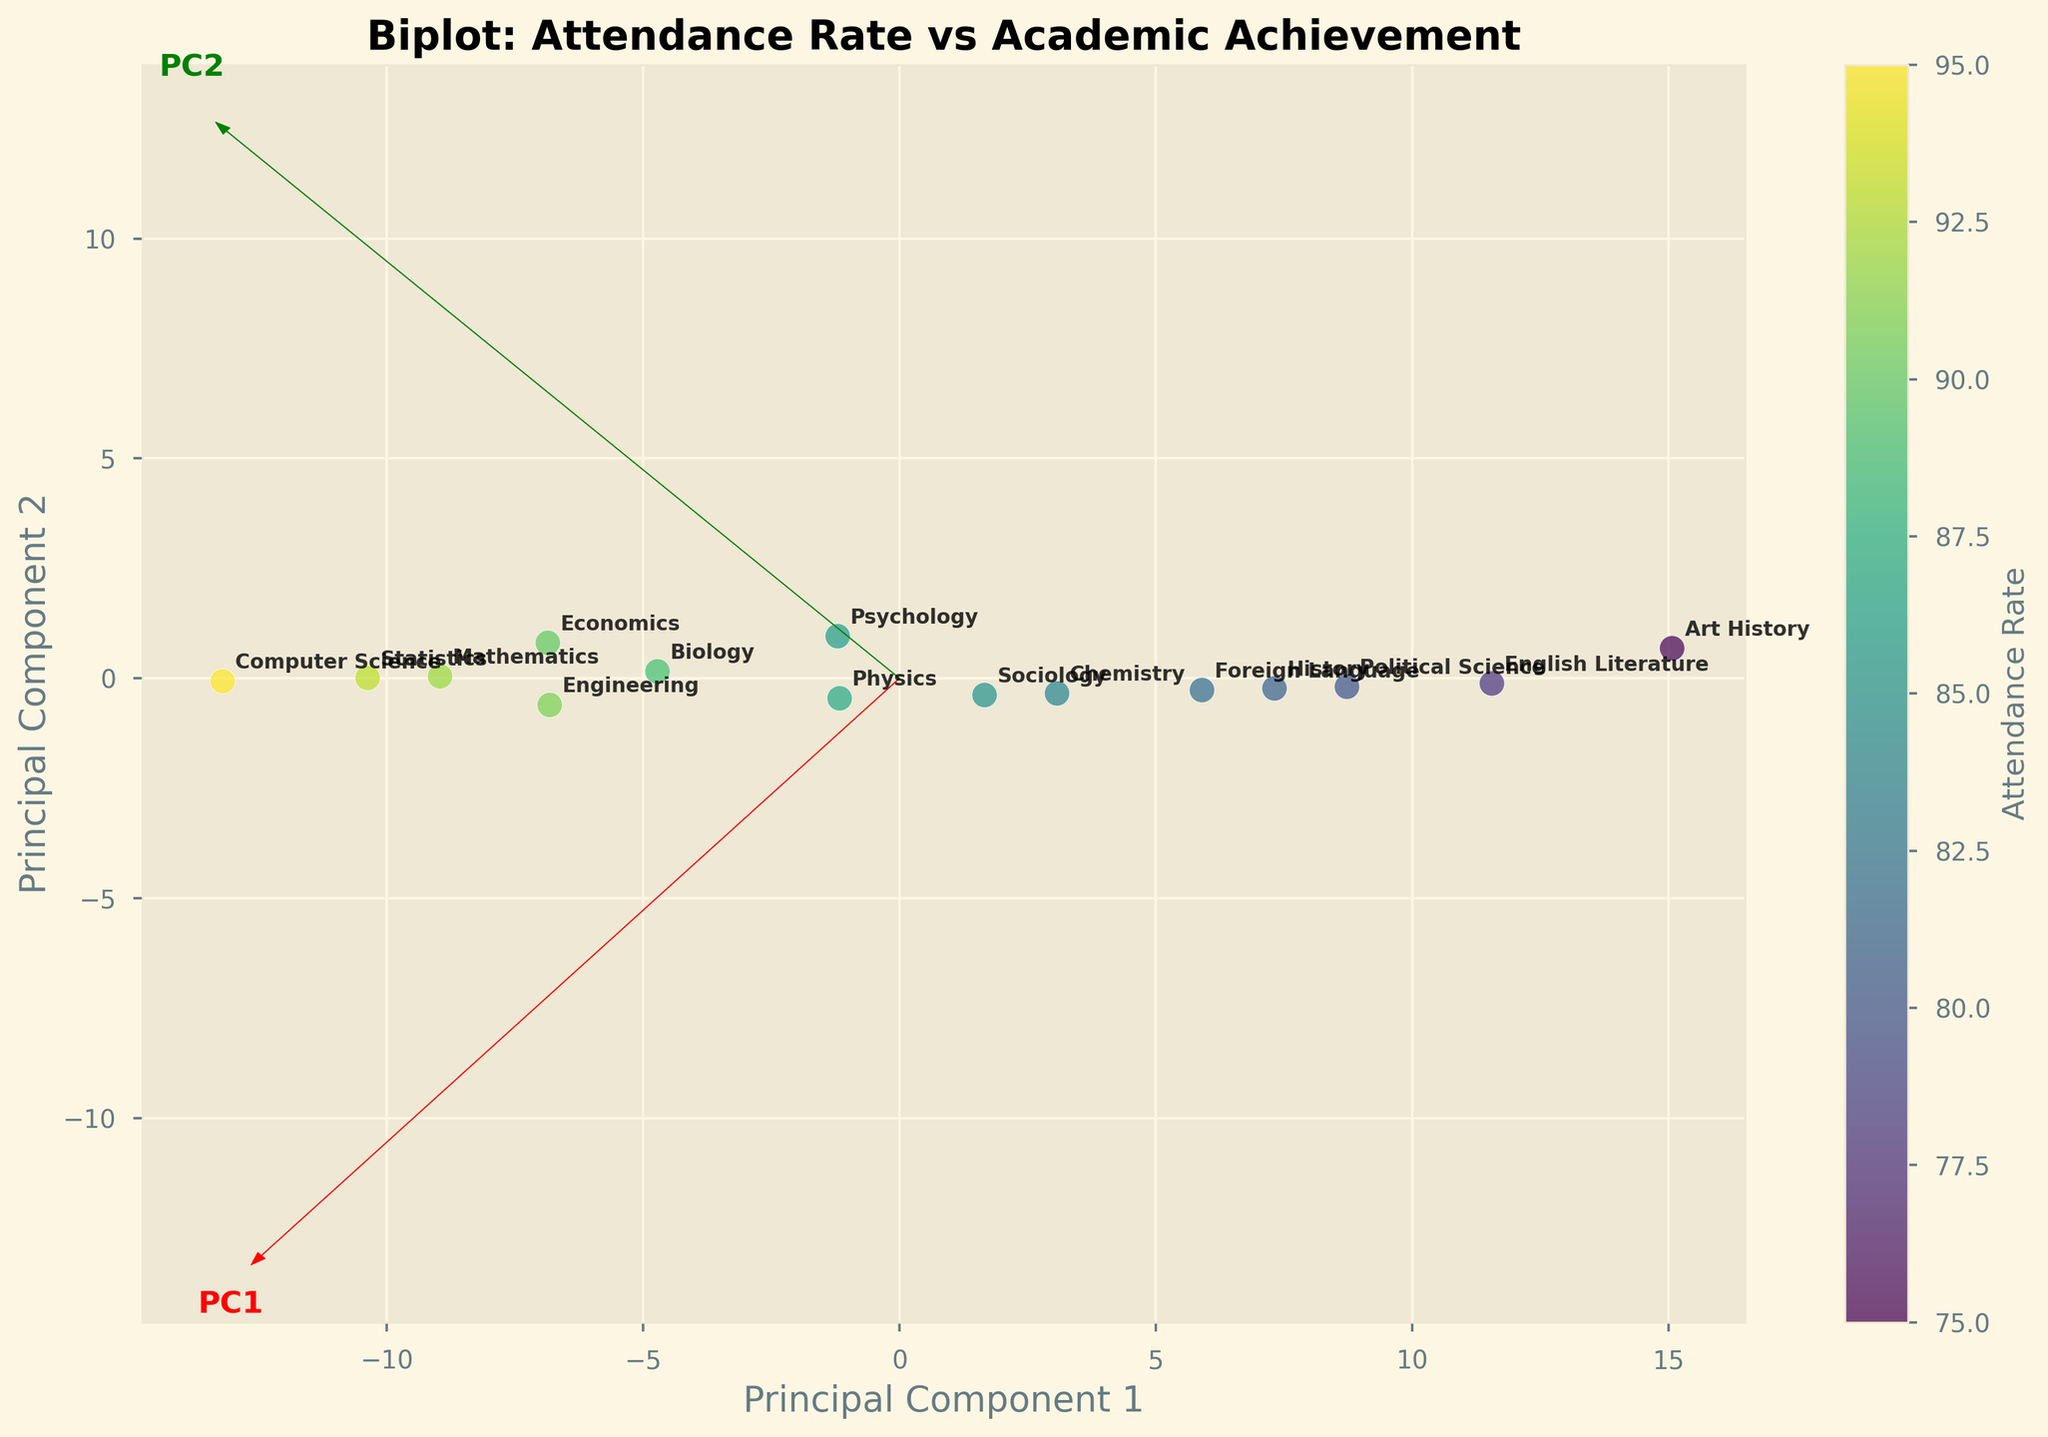What's the title of the figure? The title is displayed at the top of the figure. It reads "Biplot: Attendance Rate vs Academic Achievement".
Answer: Biplot: Attendance Rate vs Academic Achievement How many courses are represented in the plot? Each course is represented by a data point on the plot. By counting the points or the labels, we can see there are 15 courses.
Answer: 15 Which course has the highest attendance rate? By referring to the color bar and the corresponding labels on the plot, we can identify that "Computer Science" is represented by the brightest color indicating the highest attendance rate of 95%.
Answer: Computer Science Which principal component appears to explain the most variance in the data? The length of the arrows for each principal component (shown in red for PC1 and green for PC2) indicates the amount of variance they explain. The longer the arrow, the more variance explained. The red arrow (PC1) is longer.
Answer: PC1 Is the attendance rate for "Art History" above or below the median attendance rate for all courses? To find the median attendance rate, we consider the middle value of all sorted attendance rates (75, 78, 80, 81, 82, 84, 85, 86, 87, 89, 90, 91, 92, 93, 95). The median is 86 (8th value). The attendance rate for "Art History" is 75, which is below the median.
Answer: Below Compare the academic achievement of "English Literature" and "Statistics". Which course has a higher score? By locating the positions of "English Literature" and "Statistics" on the plot and checking their respective labels, "Statistics" is associated with a higher score of 89 compared to "English Literature" with 73.
Answer: Statistics What's the range of attendance rates across all courses? The lowest attendance rate is for "Art History" at 75, and the highest is for "Computer Science" at 95. The range is 95 - 75.
Answer: 20 Is there a general trend between attendance rate and academic achievement? By observing the scatter plot, there appears to be a general upward trend indicating a positive correlation between attendance rate and academic achievement; higher attendance rates don't guarantee higher achievements but they’re commonly associated with them.
Answer: Positive correlation Which courses are closest to each other in the biplot? By visually inspecting the distances between points, "Physics" and "Psychology" appear closest. They are positioned near each other and have similar projected coordinates.
Answer: Physics and Psychology How well do the principal components separate the courses based on attendance rates? The biplot shows a relatively good separation along PC1, which accounts for the most variance. Courses with higher attendance rates like "Computer Science" and "Statistics" are positioned distinctly from those with lower rates like "Art History".
Answer: Relatively well 